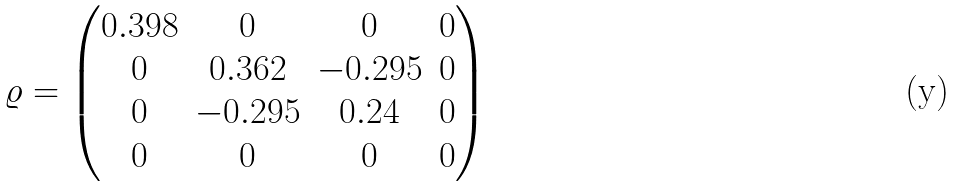Convert formula to latex. <formula><loc_0><loc_0><loc_500><loc_500>\varrho = \begin{pmatrix} 0 . 3 9 8 & 0 & 0 & 0 \\ 0 & 0 . 3 6 2 & - 0 . 2 9 5 & 0 \\ 0 & - 0 . 2 9 5 & 0 . 2 4 & 0 \\ 0 & 0 & 0 & 0 \end{pmatrix}</formula> 